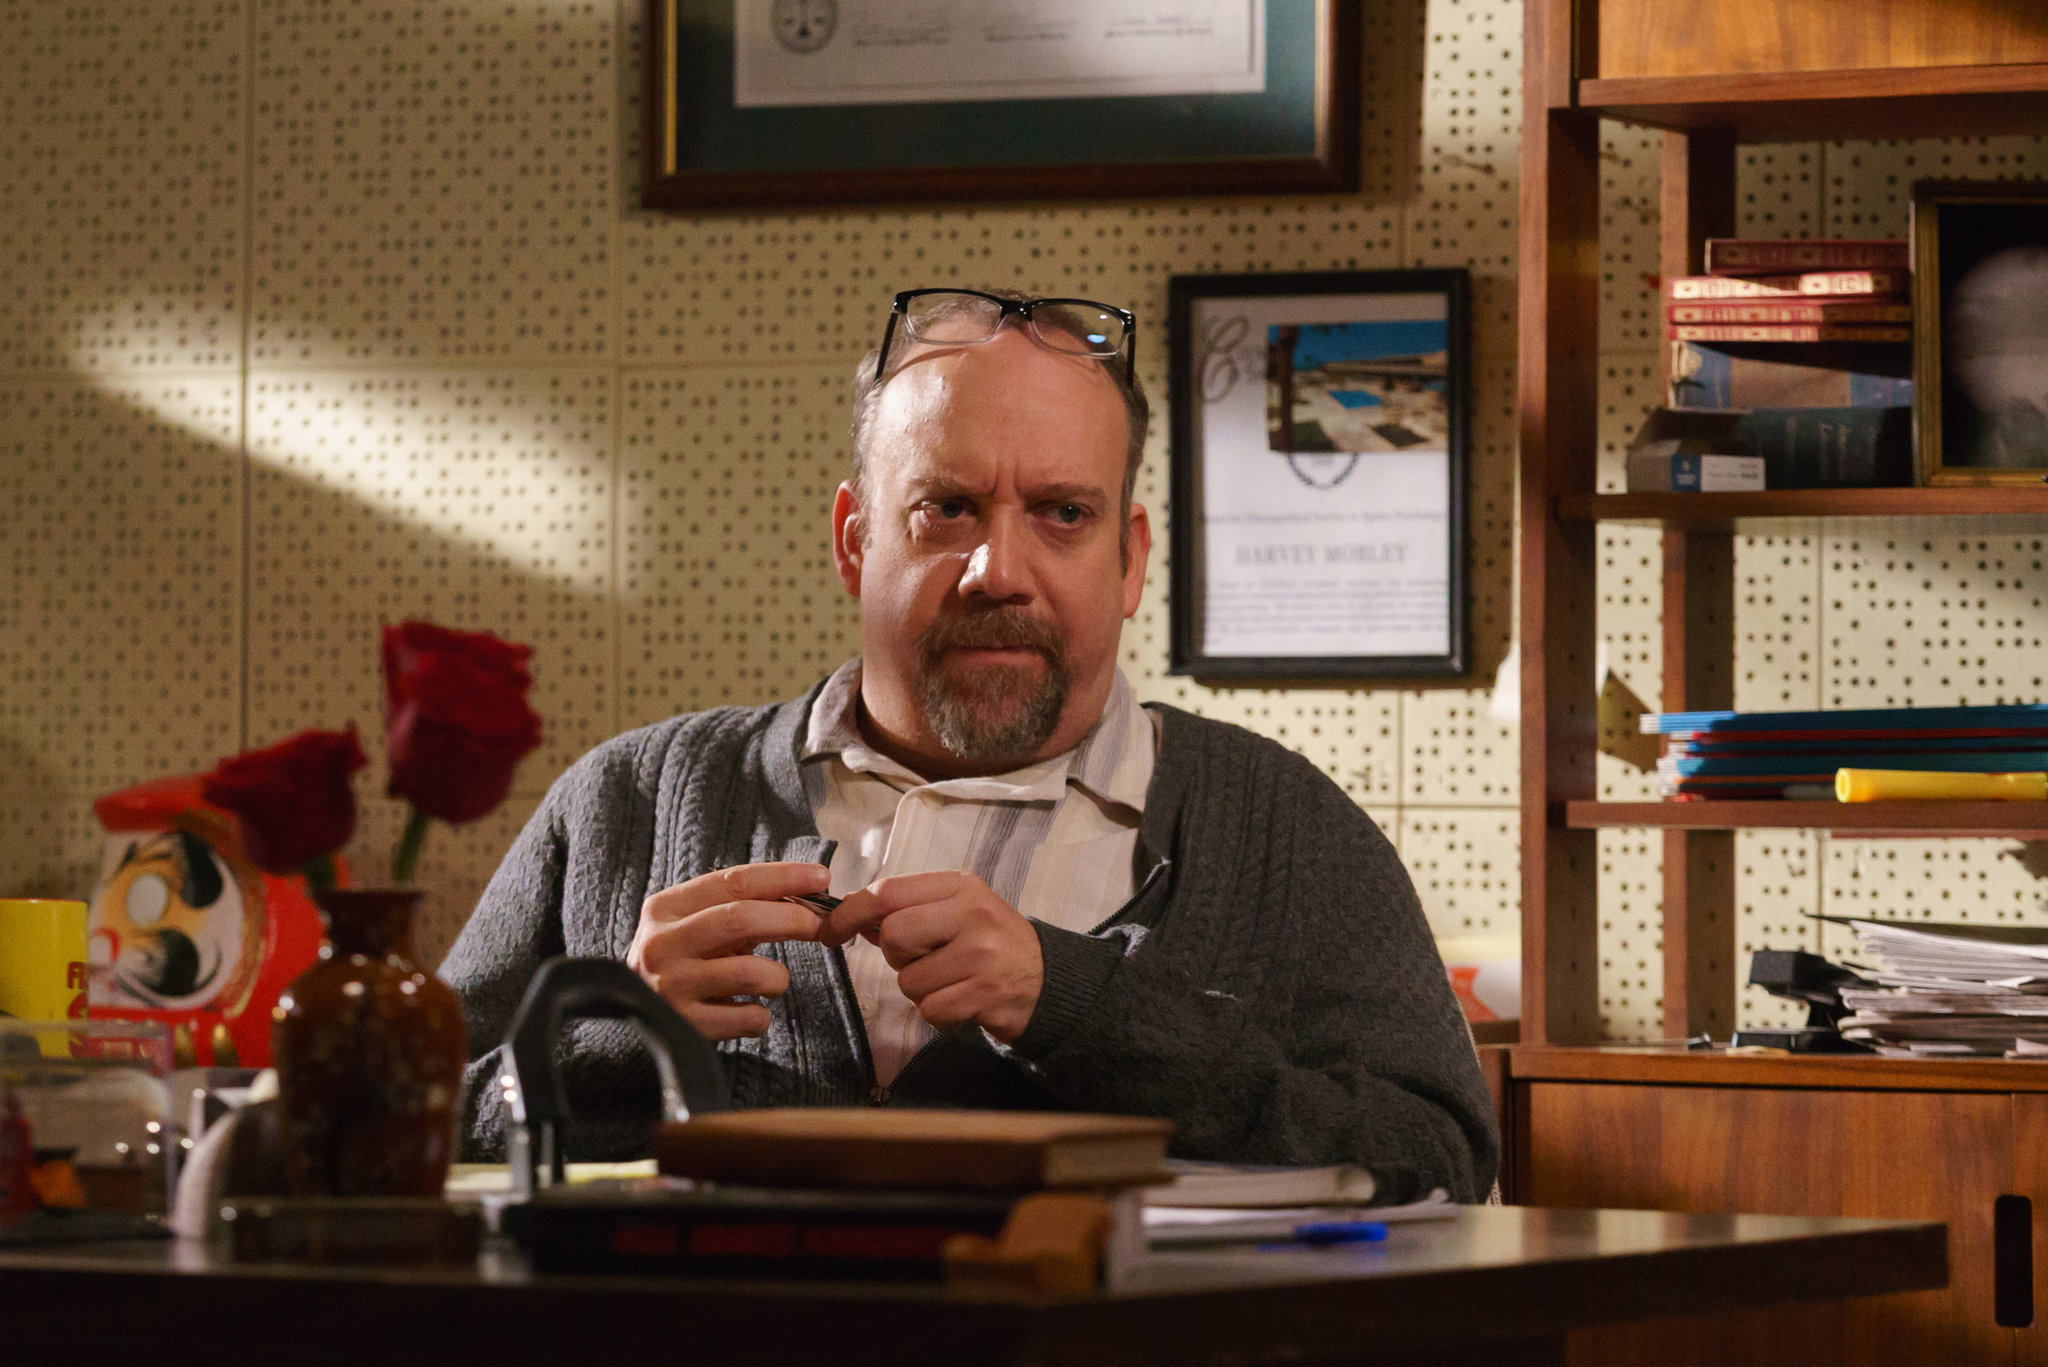What specific types of books or documents could be on the desk? The books and documents on the desk could cover a wide range of topics, depending on the man's field of interest or profession. They might include academic journals and research papers, manuscripts in various stages of completion, and a mix of reference texts and contemporary books. There could be notebooks filled with handwritten notes, diagrams, or sketches pertinent to his work. If he is a professor, there might be lecture notes, grading assignments, and curriculum planning materials. Legal pads filled with annotations and personal reflections could also be present, giving insight into his thought processes and work habits. 